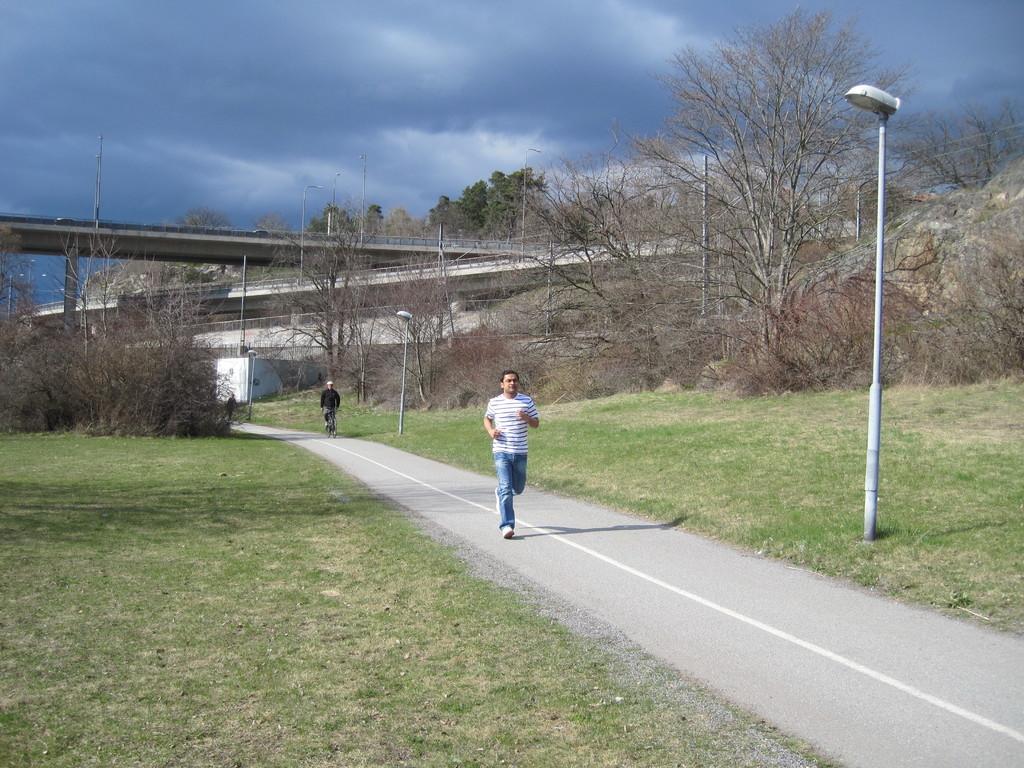Describe this image in one or two sentences. In the image there is a cloudy sky, A person is running on the road , A person is walking on the road, there is a street light in image, grassy land and many trees are there in the image. 